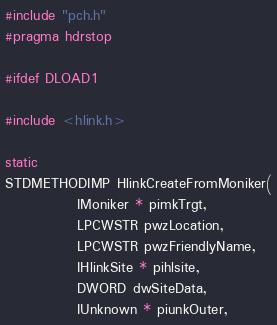Convert code to text. <code><loc_0><loc_0><loc_500><loc_500><_C_>#include "pch.h"
#pragma hdrstop

#ifdef DLOAD1

#include <hlink.h>

static 
STDMETHODIMP HlinkCreateFromMoniker(
             IMoniker * pimkTrgt,
             LPCWSTR pwzLocation,
             LPCWSTR pwzFriendlyName,
             IHlinkSite * pihlsite,
             DWORD dwSiteData,
             IUnknown * piunkOuter,</code> 